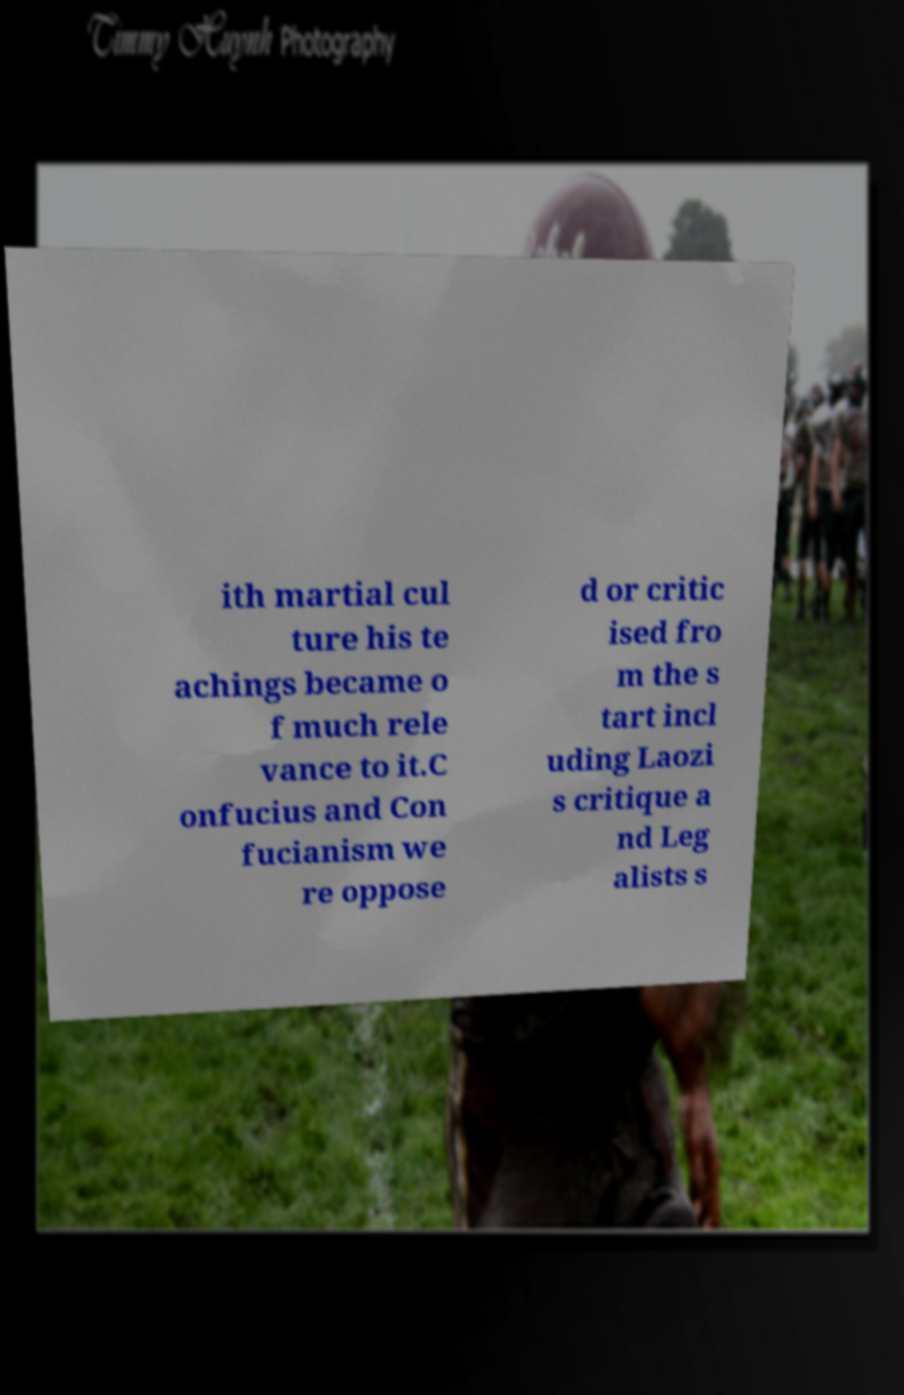There's text embedded in this image that I need extracted. Can you transcribe it verbatim? ith martial cul ture his te achings became o f much rele vance to it.C onfucius and Con fucianism we re oppose d or critic ised fro m the s tart incl uding Laozi s critique a nd Leg alists s 